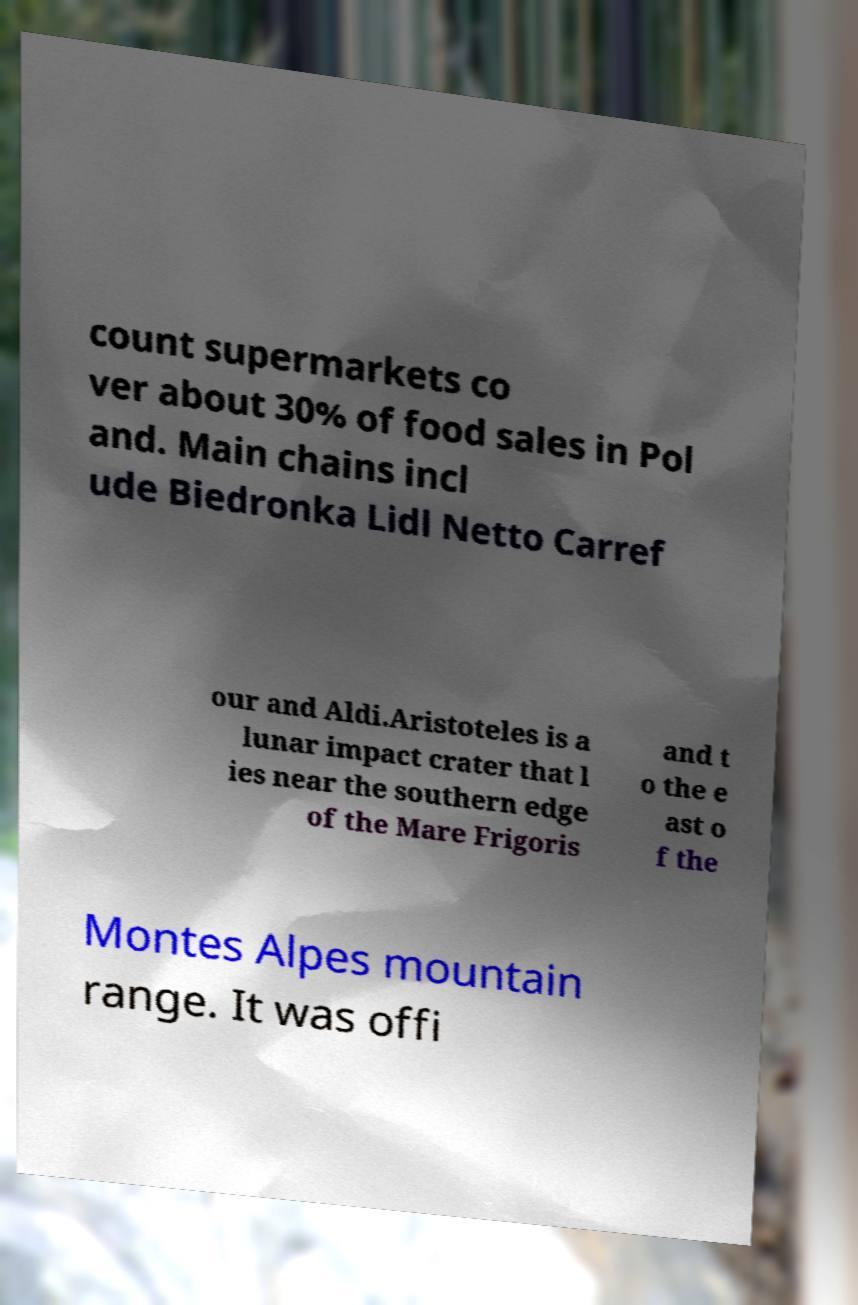What messages or text are displayed in this image? I need them in a readable, typed format. count supermarkets co ver about 30% of food sales in Pol and. Main chains incl ude Biedronka Lidl Netto Carref our and Aldi.Aristoteles is a lunar impact crater that l ies near the southern edge of the Mare Frigoris and t o the e ast o f the Montes Alpes mountain range. It was offi 